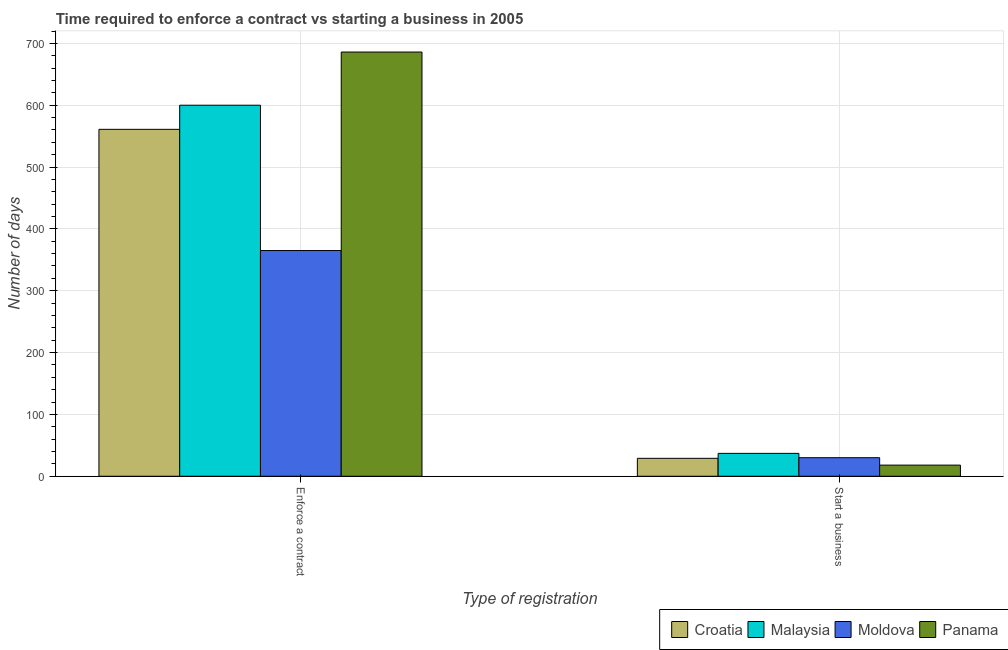Are the number of bars per tick equal to the number of legend labels?
Provide a succinct answer. Yes. What is the label of the 2nd group of bars from the left?
Make the answer very short. Start a business. What is the number of days to enforece a contract in Moldova?
Your answer should be compact. 365. Across all countries, what is the maximum number of days to enforece a contract?
Your answer should be very brief. 686. Across all countries, what is the minimum number of days to start a business?
Offer a very short reply. 18. In which country was the number of days to start a business maximum?
Keep it short and to the point. Malaysia. In which country was the number of days to enforece a contract minimum?
Your answer should be compact. Moldova. What is the total number of days to start a business in the graph?
Provide a succinct answer. 114. What is the difference between the number of days to enforece a contract in Croatia and that in Panama?
Keep it short and to the point. -125. What is the difference between the number of days to enforece a contract in Moldova and the number of days to start a business in Malaysia?
Keep it short and to the point. 328. What is the average number of days to enforece a contract per country?
Make the answer very short. 553. What is the difference between the number of days to start a business and number of days to enforece a contract in Croatia?
Provide a succinct answer. -532. In how many countries, is the number of days to start a business greater than 500 days?
Give a very brief answer. 0. What is the ratio of the number of days to start a business in Moldova to that in Croatia?
Provide a succinct answer. 1.03. Is the number of days to start a business in Panama less than that in Croatia?
Ensure brevity in your answer.  Yes. In how many countries, is the number of days to enforece a contract greater than the average number of days to enforece a contract taken over all countries?
Offer a terse response. 3. What does the 3rd bar from the left in Start a business represents?
Provide a succinct answer. Moldova. What does the 2nd bar from the right in Start a business represents?
Give a very brief answer. Moldova. How many bars are there?
Make the answer very short. 8. Are all the bars in the graph horizontal?
Keep it short and to the point. No. Are the values on the major ticks of Y-axis written in scientific E-notation?
Your answer should be very brief. No. Does the graph contain grids?
Your answer should be very brief. Yes. Where does the legend appear in the graph?
Offer a very short reply. Bottom right. How many legend labels are there?
Provide a short and direct response. 4. How are the legend labels stacked?
Your response must be concise. Horizontal. What is the title of the graph?
Make the answer very short. Time required to enforce a contract vs starting a business in 2005. Does "Tuvalu" appear as one of the legend labels in the graph?
Your response must be concise. No. What is the label or title of the X-axis?
Offer a terse response. Type of registration. What is the label or title of the Y-axis?
Make the answer very short. Number of days. What is the Number of days of Croatia in Enforce a contract?
Your answer should be compact. 561. What is the Number of days in Malaysia in Enforce a contract?
Give a very brief answer. 600. What is the Number of days of Moldova in Enforce a contract?
Provide a succinct answer. 365. What is the Number of days in Panama in Enforce a contract?
Provide a succinct answer. 686. What is the Number of days of Malaysia in Start a business?
Your response must be concise. 37. Across all Type of registration, what is the maximum Number of days in Croatia?
Keep it short and to the point. 561. Across all Type of registration, what is the maximum Number of days of Malaysia?
Offer a very short reply. 600. Across all Type of registration, what is the maximum Number of days in Moldova?
Your answer should be compact. 365. Across all Type of registration, what is the maximum Number of days of Panama?
Offer a terse response. 686. What is the total Number of days in Croatia in the graph?
Ensure brevity in your answer.  590. What is the total Number of days in Malaysia in the graph?
Your answer should be very brief. 637. What is the total Number of days of Moldova in the graph?
Provide a short and direct response. 395. What is the total Number of days of Panama in the graph?
Your answer should be very brief. 704. What is the difference between the Number of days of Croatia in Enforce a contract and that in Start a business?
Make the answer very short. 532. What is the difference between the Number of days in Malaysia in Enforce a contract and that in Start a business?
Your answer should be very brief. 563. What is the difference between the Number of days in Moldova in Enforce a contract and that in Start a business?
Provide a short and direct response. 335. What is the difference between the Number of days in Panama in Enforce a contract and that in Start a business?
Your response must be concise. 668. What is the difference between the Number of days in Croatia in Enforce a contract and the Number of days in Malaysia in Start a business?
Give a very brief answer. 524. What is the difference between the Number of days in Croatia in Enforce a contract and the Number of days in Moldova in Start a business?
Keep it short and to the point. 531. What is the difference between the Number of days in Croatia in Enforce a contract and the Number of days in Panama in Start a business?
Keep it short and to the point. 543. What is the difference between the Number of days of Malaysia in Enforce a contract and the Number of days of Moldova in Start a business?
Your answer should be very brief. 570. What is the difference between the Number of days of Malaysia in Enforce a contract and the Number of days of Panama in Start a business?
Offer a terse response. 582. What is the difference between the Number of days in Moldova in Enforce a contract and the Number of days in Panama in Start a business?
Your response must be concise. 347. What is the average Number of days of Croatia per Type of registration?
Provide a short and direct response. 295. What is the average Number of days of Malaysia per Type of registration?
Provide a succinct answer. 318.5. What is the average Number of days of Moldova per Type of registration?
Offer a terse response. 197.5. What is the average Number of days in Panama per Type of registration?
Offer a terse response. 352. What is the difference between the Number of days in Croatia and Number of days in Malaysia in Enforce a contract?
Your answer should be compact. -39. What is the difference between the Number of days of Croatia and Number of days of Moldova in Enforce a contract?
Provide a short and direct response. 196. What is the difference between the Number of days in Croatia and Number of days in Panama in Enforce a contract?
Offer a very short reply. -125. What is the difference between the Number of days of Malaysia and Number of days of Moldova in Enforce a contract?
Ensure brevity in your answer.  235. What is the difference between the Number of days in Malaysia and Number of days in Panama in Enforce a contract?
Provide a succinct answer. -86. What is the difference between the Number of days in Moldova and Number of days in Panama in Enforce a contract?
Ensure brevity in your answer.  -321. What is the difference between the Number of days of Croatia and Number of days of Moldova in Start a business?
Make the answer very short. -1. What is the difference between the Number of days of Malaysia and Number of days of Moldova in Start a business?
Offer a very short reply. 7. What is the ratio of the Number of days of Croatia in Enforce a contract to that in Start a business?
Provide a succinct answer. 19.34. What is the ratio of the Number of days in Malaysia in Enforce a contract to that in Start a business?
Provide a short and direct response. 16.22. What is the ratio of the Number of days in Moldova in Enforce a contract to that in Start a business?
Your response must be concise. 12.17. What is the ratio of the Number of days in Panama in Enforce a contract to that in Start a business?
Your answer should be very brief. 38.11. What is the difference between the highest and the second highest Number of days in Croatia?
Give a very brief answer. 532. What is the difference between the highest and the second highest Number of days of Malaysia?
Keep it short and to the point. 563. What is the difference between the highest and the second highest Number of days in Moldova?
Your answer should be very brief. 335. What is the difference between the highest and the second highest Number of days of Panama?
Provide a succinct answer. 668. What is the difference between the highest and the lowest Number of days in Croatia?
Make the answer very short. 532. What is the difference between the highest and the lowest Number of days in Malaysia?
Provide a succinct answer. 563. What is the difference between the highest and the lowest Number of days of Moldova?
Your answer should be compact. 335. What is the difference between the highest and the lowest Number of days of Panama?
Your answer should be very brief. 668. 